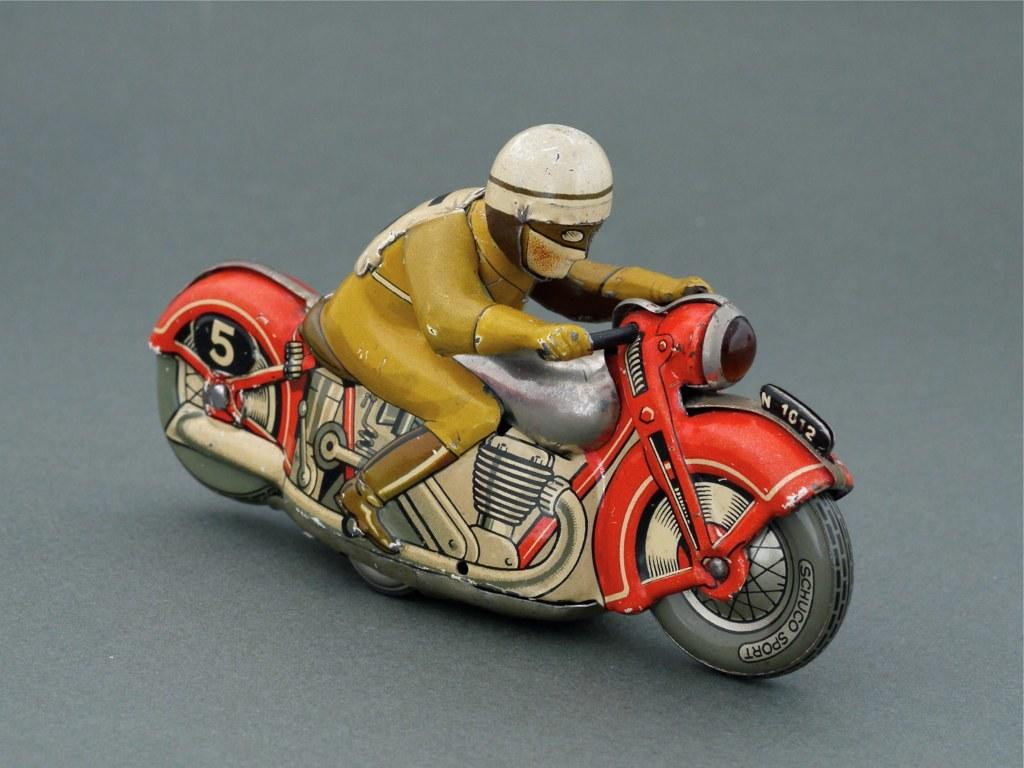What is the main subject of the image? The main subject of the image is a toy of a person riding a motorcycle. What is the toy placed on in the image? The toy is placed on an ash-colored surface. Can you see a swing in the image? No, there is no swing present in the image. Is there a volcano visible in the image? No, there is no volcano present in the image. 